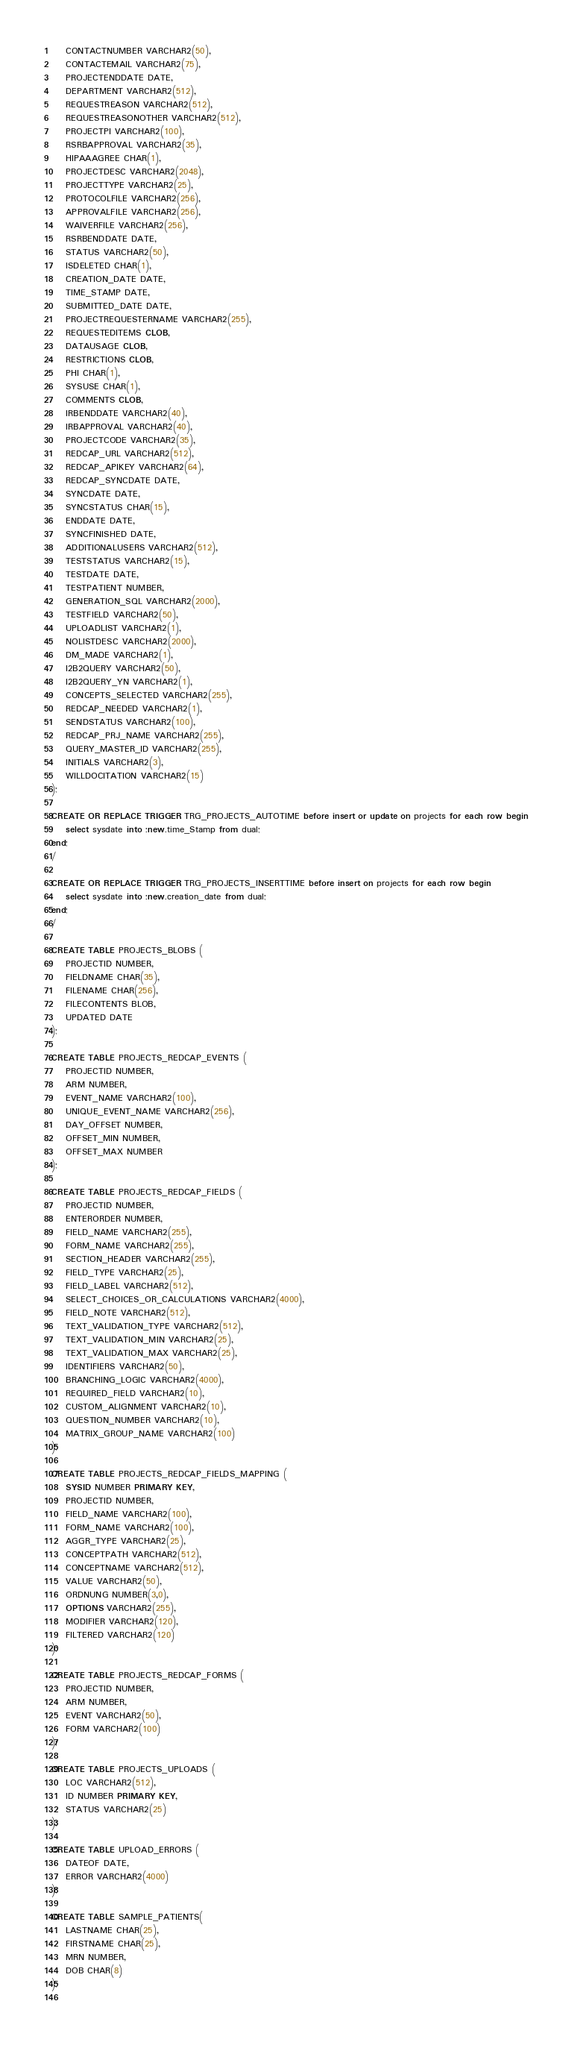Convert code to text. <code><loc_0><loc_0><loc_500><loc_500><_SQL_>	CONTACTNUMBER VARCHAR2(50), 
	CONTACTEMAIL VARCHAR2(75), 
	PROJECTENDDATE DATE, 
	DEPARTMENT VARCHAR2(512), 
	REQUESTREASON VARCHAR2(512), 
	REQUESTREASONOTHER VARCHAR2(512), 
	PROJECTPI VARCHAR2(100), 
	RSRBAPPROVAL VARCHAR2(35), 
	HIPAAAGREE CHAR(1), 
	PROJECTDESC VARCHAR2(2048), 
	PROJECTTYPE VARCHAR2(25), 
	PROTOCOLFILE VARCHAR2(256), 
	APPROVALFILE VARCHAR2(256), 
	WAIVERFILE VARCHAR2(256), 
	RSRBENDDATE DATE, 
	STATUS VARCHAR2(50), 
	ISDELETED CHAR(1), 
	CREATION_DATE DATE, 
	TIME_STAMP DATE, 
	SUBMITTED_DATE DATE, 
	PROJECTREQUESTERNAME VARCHAR2(255), 
	REQUESTEDITEMS CLOB, 
	DATAUSAGE CLOB, 
	RESTRICTIONS CLOB, 
	PHI CHAR(1), 
	SYSUSE CHAR(1), 
	COMMENTS CLOB, 
	IRBENDDATE VARCHAR2(40), 
	IRBAPPROVAL VARCHAR2(40), 
	PROJECTCODE VARCHAR2(35), 
	REDCAP_URL VARCHAR2(512), 
	REDCAP_APIKEY VARCHAR2(64), 
	REDCAP_SYNCDATE DATE, 
	SYNCDATE DATE, 
	SYNCSTATUS CHAR(15), 
	ENDDATE DATE, 
	SYNCFINISHED DATE, 
	ADDITIONALUSERS VARCHAR2(512), 
	TESTSTATUS VARCHAR2(15), 
	TESTDATE DATE, 
	TESTPATIENT NUMBER, 
	GENERATION_SQL VARCHAR2(2000), 
	TESTFIELD VARCHAR2(50), 
	UPLOADLIST VARCHAR2(1), 
	NOLISTDESC VARCHAR2(2000), 
	DM_MADE VARCHAR2(1), 
	I2B2QUERY VARCHAR2(50), 
	I2B2QUERY_YN VARCHAR2(1), 
	CONCEPTS_SELECTED VARCHAR2(255), 
	REDCAP_NEEDED VARCHAR2(1), 
	SENDSTATUS VARCHAR2(100), 
	REDCAP_PRJ_NAME VARCHAR2(255), 
	QUERY_MASTER_ID VARCHAR2(255),
	INITIALS VARCHAR2(3),
	WILLDOCITATION VARCHAR2(15)
);
  
CREATE OR REPLACE TRIGGER TRG_PROJECTS_AUTOTIME before insert or update on projects for each row begin
	select sysdate into :new.time_Stamp from dual;
end;
/

CREATE OR REPLACE TRIGGER TRG_PROJECTS_INSERTTIME before insert on projects for each row begin
	select sysdate into :new.creation_date from dual;
end;
/

CREATE TABLE PROJECTS_BLOBS (
	PROJECTID NUMBER, 
	FIELDNAME CHAR(35), 
	FILENAME CHAR(256), 
	FILECONTENTS BLOB, 
	UPDATED DATE
);

CREATE TABLE PROJECTS_REDCAP_EVENTS (
	PROJECTID NUMBER, 
	ARM NUMBER, 
	EVENT_NAME VARCHAR2(100), 
	UNIQUE_EVENT_NAME VARCHAR2(256), 
	DAY_OFFSET NUMBER, 
	OFFSET_MIN NUMBER, 
	OFFSET_MAX NUMBER
);
  
CREATE TABLE PROJECTS_REDCAP_FIELDS (
	PROJECTID NUMBER, 
	ENTERORDER NUMBER, 
	FIELD_NAME VARCHAR2(255), 
	FORM_NAME VARCHAR2(255), 
	SECTION_HEADER VARCHAR2(255), 
	FIELD_TYPE VARCHAR2(25), 
	FIELD_LABEL VARCHAR2(512), 
	SELECT_CHOICES_OR_CALCULATIONS VARCHAR2(4000), 
	FIELD_NOTE VARCHAR2(512), 
	TEXT_VALIDATION_TYPE VARCHAR2(512), 
	TEXT_VALIDATION_MIN VARCHAR2(25), 
	TEXT_VALIDATION_MAX VARCHAR2(25), 
	IDENTIFIERS VARCHAR2(50), 
	BRANCHING_LOGIC VARCHAR2(4000), 
	REQUIRED_FIELD VARCHAR2(10), 
	CUSTOM_ALIGNMENT VARCHAR2(10), 
	QUESTION_NUMBER VARCHAR2(10), 
	MATRIX_GROUP_NAME VARCHAR2(100)
);
  
CREATE TABLE PROJECTS_REDCAP_FIELDS_MAPPING (
	SYSID NUMBER PRIMARY KEY, 
	PROJECTID NUMBER, 
	FIELD_NAME VARCHAR2(100), 
	FORM_NAME VARCHAR2(100), 
	AGGR_TYPE VARCHAR2(25), 
	CONCEPTPATH VARCHAR2(512), 
	CONCEPTNAME VARCHAR2(512), 
	VALUE VARCHAR2(50), 
	ORDNUNG NUMBER(3,0), 
	OPTIONS VARCHAR2(255), 
	MODIFIER VARCHAR2(120), 
	FILTERED VARCHAR2(120)
);
  
CREATE TABLE PROJECTS_REDCAP_FORMS (
	PROJECTID NUMBER, 
	ARM NUMBER, 
	EVENT VARCHAR2(50), 
	FORM VARCHAR2(100)
);
  
CREATE TABLE PROJECTS_UPLOADS (
	LOC VARCHAR2(512), 
	ID NUMBER PRIMARY KEY, 
	STATUS VARCHAR2(25)
);
  
CREATE TABLE UPLOAD_ERRORS (
	DATEOF DATE, 
	ERROR VARCHAR2(4000)
);
  
CREATE TABLE SAMPLE_PATIENTS(
	LASTNAME CHAR(25), 
	FIRSTNAME CHAR(25), 
	MRN NUMBER, 
	DOB CHAR(8)
);
 </code> 